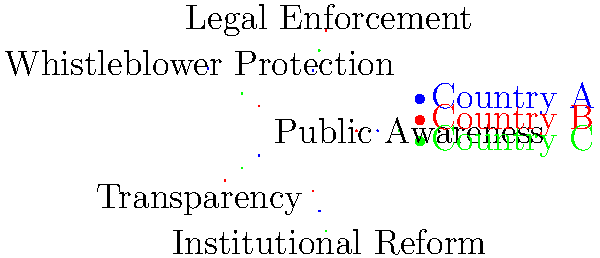Based on the radar chart comparing anti-corruption measures in three countries, which country appears to have the most balanced approach across all five categories, and why is this significant for a Ghanaian journalism student investigating corruption? To answer this question, let's analyze the radar chart step-by-step:

1. The chart compares five anti-corruption measures across three countries: A (blue), B (red), and C (green).

2. The measures are:
   - Public Awareness
   - Legal Enforcement
   - Whistleblower Protection
   - Transparency
   - Institutional Reform

3. Examine each country's performance:
   - Country A: Strong in Whistleblower Protection and Public Awareness, weak in Transparency.
   - Country B: Strong in Legal Enforcement, weak in Whistleblower Protection.
   - Country C: Strong in Public Awareness and Institutional Reform, relatively balanced in others.

4. Country C shows the most balanced approach, with scores ranging from 3 to 5 across all categories.

5. A balanced approach is significant for a Ghanaian journalism student because:
   a) It demonstrates a comprehensive strategy to combat corruption.
   b) It provides multiple angles for investigative reporting.
   c) It reflects a holistic understanding of corruption's complexities.
   d) It offers a model for potential improvements in Ghana's anti-corruption efforts.

6. A balanced approach allows for:
   - Increased public engagement through awareness
   - Strong legal frameworks and enforcement
   - Protection for those exposing corruption
   - Greater access to information for journalists
   - Systemic changes to prevent future corruption

For a journalism student passionate about fighting corruption, studying a balanced approach offers valuable insights into effective anti-corruption strategies and provides a comprehensive framework for investigating and reporting on corruption issues in Ghana.
Answer: Country C; balanced approach offers comprehensive insights for investigating corruption 